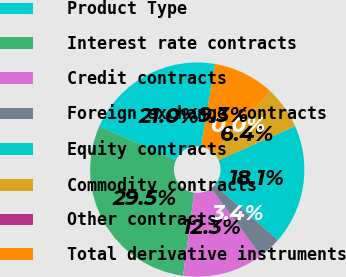Convert chart to OTSL. <chart><loc_0><loc_0><loc_500><loc_500><pie_chart><fcel>Product Type<fcel>Interest rate contracts<fcel>Credit contracts<fcel>Foreign exchange contracts<fcel>Equity contracts<fcel>Commodity contracts<fcel>Other contracts<fcel>Total derivative instruments<nl><fcel>21.02%<fcel>29.51%<fcel>12.27%<fcel>3.42%<fcel>18.07%<fcel>6.37%<fcel>0.01%<fcel>9.32%<nl></chart> 